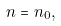Convert formula to latex. <formula><loc_0><loc_0><loc_500><loc_500>n = n _ { 0 } ,</formula> 